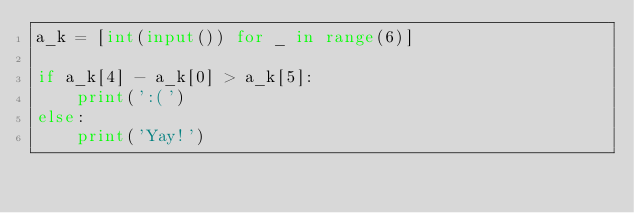<code> <loc_0><loc_0><loc_500><loc_500><_Python_>a_k = [int(input()) for _ in range(6)]

if a_k[4] - a_k[0] > a_k[5]:
    print(':(')
else:
    print('Yay!')</code> 